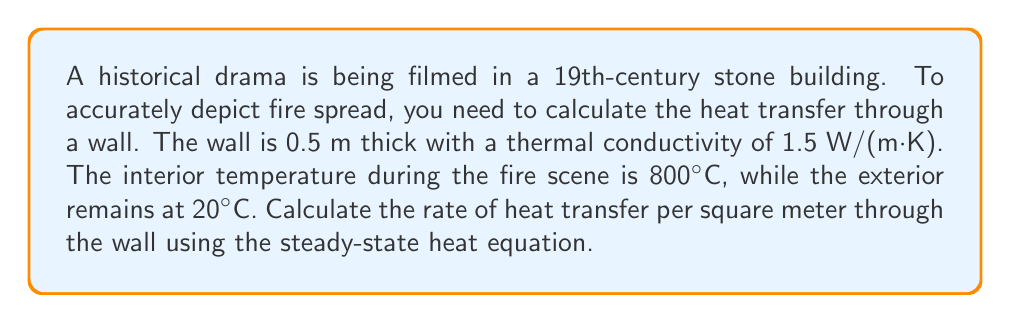Give your solution to this math problem. To solve this problem, we'll use the steady-state heat equation:

$$q = -k \frac{dT}{dx}$$

Where:
$q$ = heat flux (W/m²)
$k$ = thermal conductivity (W/(m·K))
$\frac{dT}{dx}$ = temperature gradient (K/m)

Step 1: Identify the known values
- Thermal conductivity, $k = 1.5$ W/(m·K)
- Wall thickness, $\Delta x = 0.5$ m
- Interior temperature, $T_1 = 800°C = 1073.15$ K
- Exterior temperature, $T_2 = 20°C = 293.15$ K

Step 2: Calculate the temperature gradient
$$\frac{dT}{dx} = \frac{T_2 - T_1}{\Delta x} = \frac{293.15 - 1073.15}{0.5} = -1560 \text{ K/m}$$

Step 3: Apply the steady-state heat equation
$$q = -k \frac{dT}{dx} = -(1.5 \text{ W/(m·K)})(-1560 \text{ K/m}) = 2340 \text{ W/m²}$$

Therefore, the rate of heat transfer through the wall is 2340 W/m².
Answer: 2340 W/m² 